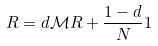Convert formula to latex. <formula><loc_0><loc_0><loc_500><loc_500>R = d { \mathcal { M } } R + { \frac { 1 - d } { N } } 1</formula> 